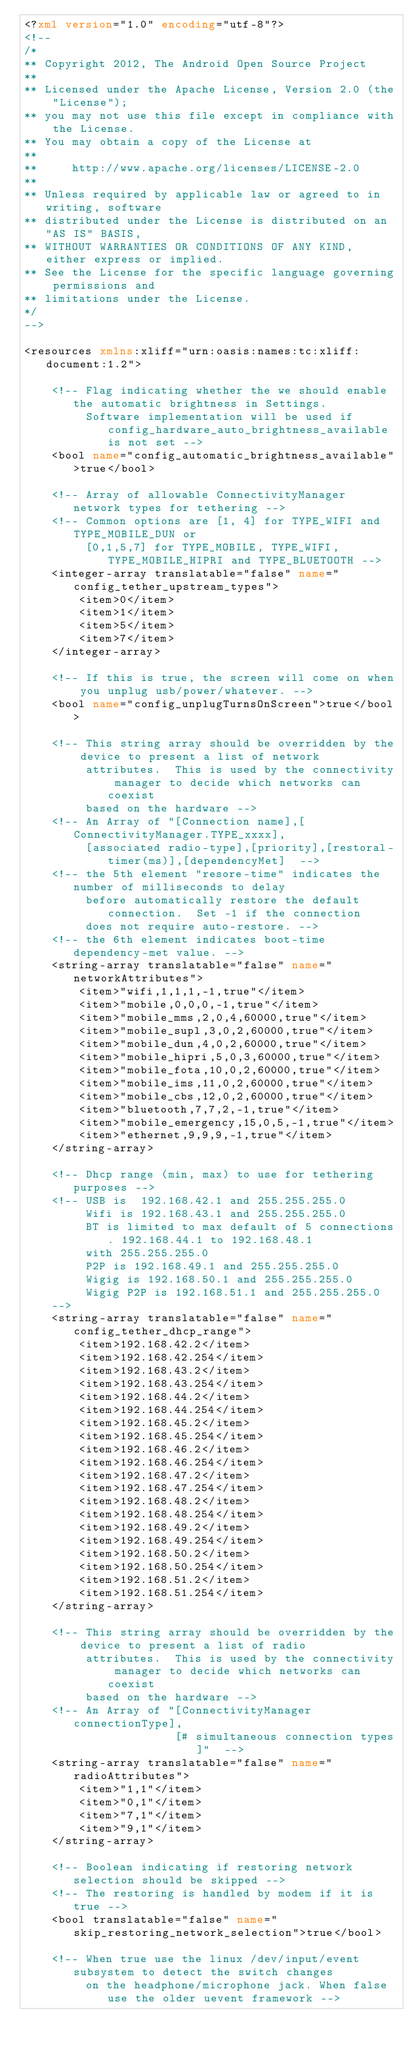<code> <loc_0><loc_0><loc_500><loc_500><_XML_><?xml version="1.0" encoding="utf-8"?>
<!--
/*
** Copyright 2012, The Android Open Source Project
**
** Licensed under the Apache License, Version 2.0 (the "License");
** you may not use this file except in compliance with the License.
** You may obtain a copy of the License at
**
**     http://www.apache.org/licenses/LICENSE-2.0
**
** Unless required by applicable law or agreed to in writing, software
** distributed under the License is distributed on an "AS IS" BASIS,
** WITHOUT WARRANTIES OR CONDITIONS OF ANY KIND, either express or implied.
** See the License for the specific language governing permissions and
** limitations under the License.
*/
-->

<resources xmlns:xliff="urn:oasis:names:tc:xliff:document:1.2">

    <!-- Flag indicating whether the we should enable the automatic brightness in Settings.
         Software implementation will be used if config_hardware_auto_brightness_available is not set -->
    <bool name="config_automatic_brightness_available">true</bool>

    <!-- Array of allowable ConnectivityManager network types for tethering -->
    <!-- Common options are [1, 4] for TYPE_WIFI and TYPE_MOBILE_DUN or
         [0,1,5,7] for TYPE_MOBILE, TYPE_WIFI, TYPE_MOBILE_HIPRI and TYPE_BLUETOOTH -->
    <integer-array translatable="false" name="config_tether_upstream_types">
        <item>0</item>
        <item>1</item>
        <item>5</item>
        <item>7</item>
    </integer-array>

    <!-- If this is true, the screen will come on when you unplug usb/power/whatever. -->
    <bool name="config_unplugTurnsOnScreen">true</bool>

    <!-- This string array should be overridden by the device to present a list of network
         attributes.  This is used by the connectivity manager to decide which networks can coexist
         based on the hardware -->
    <!-- An Array of "[Connection name],[ConnectivityManager.TYPE_xxxx],
         [associated radio-type],[priority],[restoral-timer(ms)],[dependencyMet]  -->
    <!-- the 5th element "resore-time" indicates the number of milliseconds to delay
         before automatically restore the default connection.  Set -1 if the connection
         does not require auto-restore. -->
    <!-- the 6th element indicates boot-time dependency-met value. -->
    <string-array translatable="false" name="networkAttributes">
        <item>"wifi,1,1,1,-1,true"</item>
        <item>"mobile,0,0,0,-1,true"</item>
        <item>"mobile_mms,2,0,4,60000,true"</item>
        <item>"mobile_supl,3,0,2,60000,true"</item>
        <item>"mobile_dun,4,0,2,60000,true"</item>
        <item>"mobile_hipri,5,0,3,60000,true"</item>
        <item>"mobile_fota,10,0,2,60000,true"</item>
        <item>"mobile_ims,11,0,2,60000,true"</item>
        <item>"mobile_cbs,12,0,2,60000,true"</item>
        <item>"bluetooth,7,7,2,-1,true"</item>
        <item>"mobile_emergency,15,0,5,-1,true"</item>
        <item>"ethernet,9,9,9,-1,true"</item>
    </string-array>

    <!-- Dhcp range (min, max) to use for tethering purposes -->
    <!-- USB is  192.168.42.1 and 255.255.255.0
         Wifi is 192.168.43.1 and 255.255.255.0
         BT is limited to max default of 5 connections. 192.168.44.1 to 192.168.48.1
         with 255.255.255.0
         P2P is 192.168.49.1 and 255.255.255.0
         Wigig is 192.168.50.1 and 255.255.255.0
         Wigig P2P is 192.168.51.1 and 255.255.255.0
    -->
    <string-array translatable="false" name="config_tether_dhcp_range">
        <item>192.168.42.2</item>
        <item>192.168.42.254</item>
        <item>192.168.43.2</item>
        <item>192.168.43.254</item>
        <item>192.168.44.2</item>
        <item>192.168.44.254</item>
        <item>192.168.45.2</item>
        <item>192.168.45.254</item>
        <item>192.168.46.2</item>
        <item>192.168.46.254</item>
        <item>192.168.47.2</item>
        <item>192.168.47.254</item>
        <item>192.168.48.2</item>
        <item>192.168.48.254</item>
        <item>192.168.49.2</item>
        <item>192.168.49.254</item>
        <item>192.168.50.2</item>
        <item>192.168.50.254</item>
        <item>192.168.51.2</item>
        <item>192.168.51.254</item>
    </string-array>

    <!-- This string array should be overridden by the device to present a list of radio
         attributes.  This is used by the connectivity manager to decide which networks can coexist
         based on the hardware -->
    <!-- An Array of "[ConnectivityManager connectionType],
                      [# simultaneous connection types]"  -->
    <string-array translatable="false" name="radioAttributes">
        <item>"1,1"</item>
        <item>"0,1"</item>
        <item>"7,1"</item>
        <item>"9,1"</item>
    </string-array>

    <!-- Boolean indicating if restoring network selection should be skipped -->
    <!-- The restoring is handled by modem if it is true -->
    <bool translatable="false" name="skip_restoring_network_selection">true</bool>

    <!-- When true use the linux /dev/input/event subsystem to detect the switch changes
         on the headphone/microphone jack. When false use the older uevent framework --></code> 